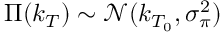Convert formula to latex. <formula><loc_0><loc_0><loc_500><loc_500>\Pi ( k _ { T } ) \sim \mathcal { N } ( k _ { T _ { 0 } } , \sigma _ { \pi } ^ { 2 } )</formula> 